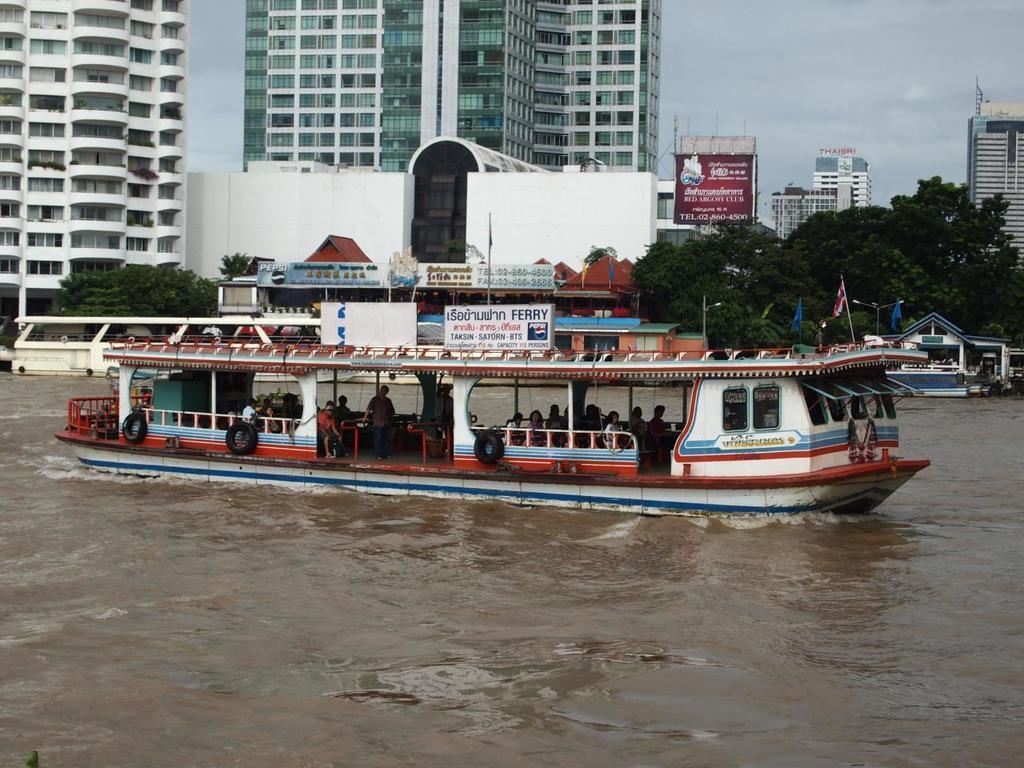Please provide a concise description of this image. In this picture I can see at the bottom there is water, in the middle there is a boat. In the background there are trees and buildings, on the right side there is a hoarding, at the top there is the sky. 